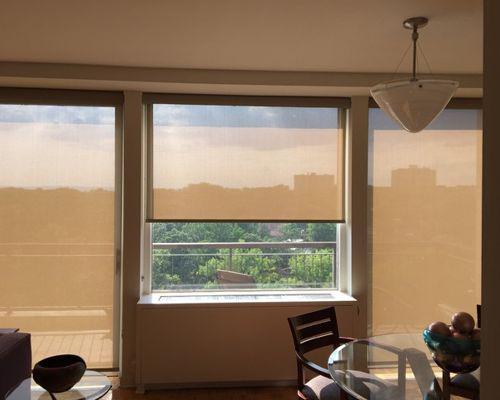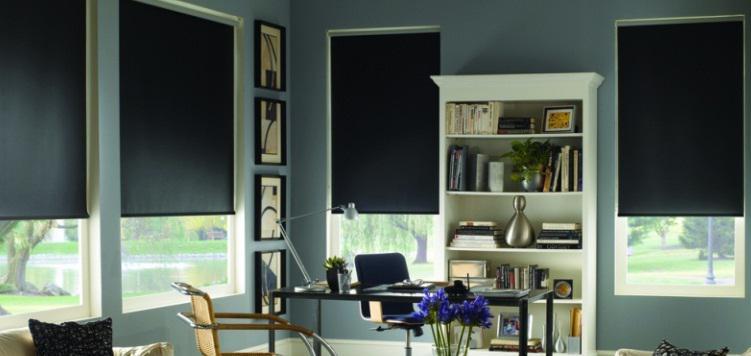The first image is the image on the left, the second image is the image on the right. Evaluate the accuracy of this statement regarding the images: "The left and right image contains the a total of four window.". Is it true? Answer yes or no. No. 